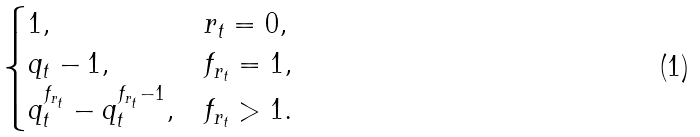Convert formula to latex. <formula><loc_0><loc_0><loc_500><loc_500>\begin{cases} 1 , & r _ { t } = 0 , \\ q _ { t } - 1 , & f _ { r _ { t } } = 1 , \\ q _ { t } ^ { f _ { r _ { t } } } - q _ { t } ^ { f _ { r _ { t } } - 1 } , & f _ { r _ { t } } > 1 . \end{cases}</formula> 